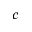Convert formula to latex. <formula><loc_0><loc_0><loc_500><loc_500>c</formula> 